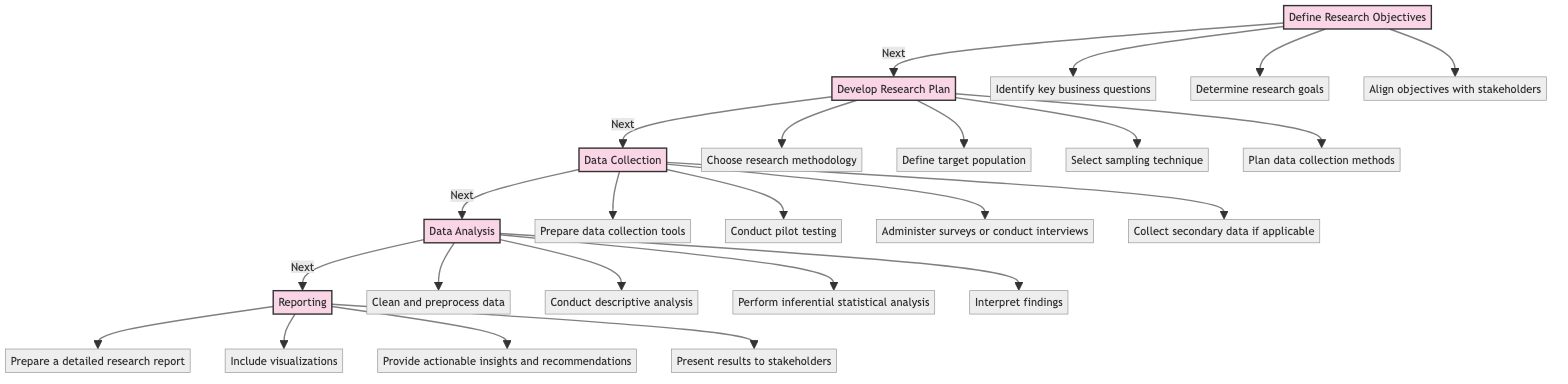What is the first stage of the process? The diagram begins with the stage labeled "Define Research Objectives," which is positioned at the top of the flowchart.
Answer: Define Research Objectives How many steps are in the "Data Analysis" stage? In the "Data Analysis" stage, there are four specific steps listed: clean and preprocess data, conduct descriptive analysis, perform inferential statistical analysis, and interpret findings.
Answer: Four What precedes the "Reporting" stage? The stage that immediately goes before the "Reporting" stage is "Data Analysis," which is indicated by the flow from one node to another in the diagram.
Answer: Data Analysis Which two stages directly follow "Develop Research Plan"? After "Develop Research Plan," the diagram shows two direct connections to "Data Collection," indicating a linear flow from the planning to the collection phase.
Answer: Data Collection What is the last step in the "Data Collection" stage? The last step listed under the "Data Collection" stage is "Collect secondary data if applicable." This denotes the concluding action in this stage, based on the flowchart sequence.
Answer: Collect secondary data if applicable What overall purpose does the "Define Research Objectives" stage serve? The "Define Research Objectives" stage sets the foundational goals for the study, establishing clarity on the business questions, research objectives, and stakeholder alignment, which is essential for guiding the research process.
Answer: Establish goals and scope How many total stages are indicated in the diagram? The diagram has a total of five distinct stages, each representing a critical phase in the market research study process: Define Research Objectives, Develop Research Plan, Data Collection, Data Analysis, and Reporting.
Answer: Five Which step in the "Develop Research Plan" involves choosing a method? The step titled "Choose research methodology" is directly mentioned under the "Develop Research Plan" stage and involves selecting the approach for conducting the research.
Answer: Choose research methodology How do the "Data Collection" and "Data Analysis" stages connect? The flow indicates that after completing the "Data Collection," the next direct phase is "Data Analysis," demonstrating a sequential link from data gathering to the analysis process.
Answer: Data Analysis 